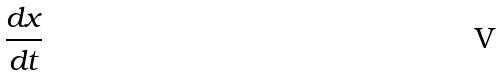<formula> <loc_0><loc_0><loc_500><loc_500>\frac { d x } { d t }</formula> 